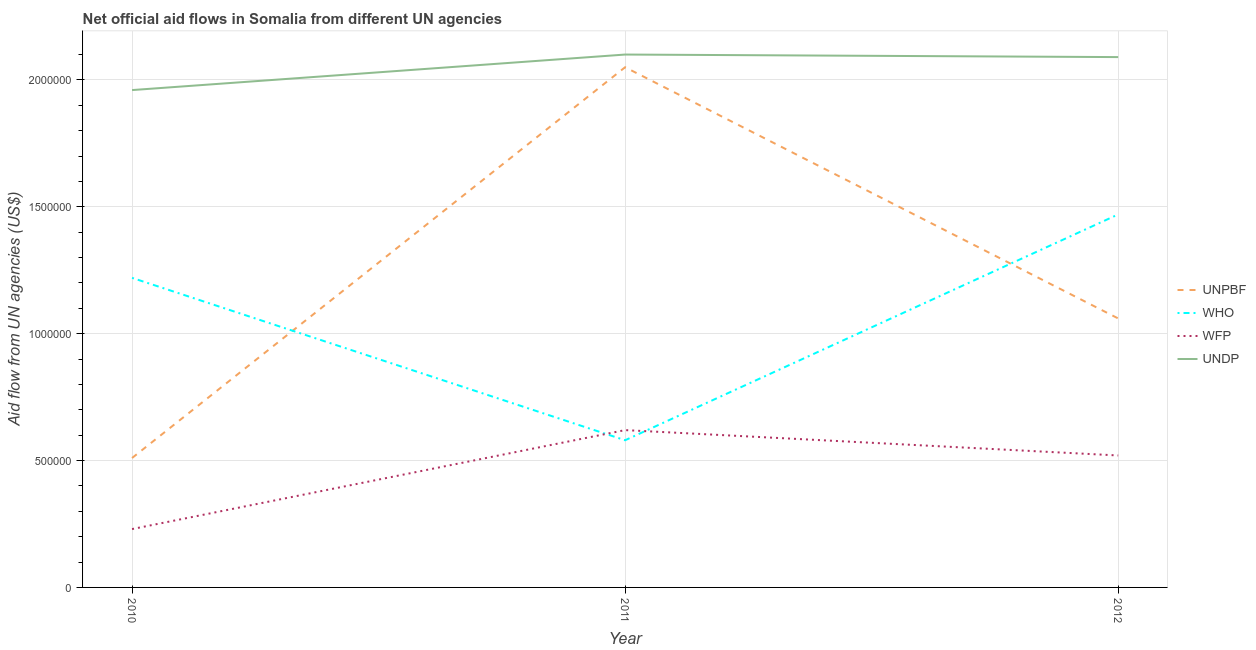What is the amount of aid given by wfp in 2010?
Keep it short and to the point. 2.30e+05. Across all years, what is the maximum amount of aid given by undp?
Ensure brevity in your answer.  2.10e+06. Across all years, what is the minimum amount of aid given by wfp?
Your answer should be compact. 2.30e+05. In which year was the amount of aid given by who maximum?
Offer a very short reply. 2012. In which year was the amount of aid given by wfp minimum?
Give a very brief answer. 2010. What is the total amount of aid given by who in the graph?
Your answer should be very brief. 3.27e+06. What is the difference between the amount of aid given by undp in 2010 and that in 2012?
Ensure brevity in your answer.  -1.30e+05. What is the difference between the amount of aid given by undp in 2012 and the amount of aid given by who in 2010?
Offer a very short reply. 8.70e+05. What is the average amount of aid given by who per year?
Your response must be concise. 1.09e+06. In the year 2012, what is the difference between the amount of aid given by unpbf and amount of aid given by who?
Give a very brief answer. -4.10e+05. In how many years, is the amount of aid given by unpbf greater than 2000000 US$?
Give a very brief answer. 1. What is the ratio of the amount of aid given by unpbf in 2010 to that in 2011?
Your response must be concise. 0.25. Is the amount of aid given by wfp in 2010 less than that in 2012?
Offer a terse response. Yes. Is the difference between the amount of aid given by who in 2011 and 2012 greater than the difference between the amount of aid given by wfp in 2011 and 2012?
Keep it short and to the point. No. What is the difference between the highest and the second highest amount of aid given by unpbf?
Give a very brief answer. 9.90e+05. What is the difference between the highest and the lowest amount of aid given by undp?
Offer a very short reply. 1.40e+05. Is it the case that in every year, the sum of the amount of aid given by wfp and amount of aid given by who is greater than the sum of amount of aid given by unpbf and amount of aid given by undp?
Give a very brief answer. Yes. Does the amount of aid given by unpbf monotonically increase over the years?
Offer a very short reply. No. Is the amount of aid given by undp strictly greater than the amount of aid given by unpbf over the years?
Offer a terse response. Yes. How many lines are there?
Provide a short and direct response. 4. Does the graph contain any zero values?
Give a very brief answer. No. What is the title of the graph?
Provide a succinct answer. Net official aid flows in Somalia from different UN agencies. Does "Interest Payments" appear as one of the legend labels in the graph?
Offer a terse response. No. What is the label or title of the X-axis?
Your answer should be very brief. Year. What is the label or title of the Y-axis?
Offer a very short reply. Aid flow from UN agencies (US$). What is the Aid flow from UN agencies (US$) in UNPBF in 2010?
Your answer should be very brief. 5.10e+05. What is the Aid flow from UN agencies (US$) of WHO in 2010?
Your answer should be very brief. 1.22e+06. What is the Aid flow from UN agencies (US$) in UNDP in 2010?
Provide a short and direct response. 1.96e+06. What is the Aid flow from UN agencies (US$) of UNPBF in 2011?
Your answer should be compact. 2.05e+06. What is the Aid flow from UN agencies (US$) of WHO in 2011?
Give a very brief answer. 5.80e+05. What is the Aid flow from UN agencies (US$) of WFP in 2011?
Offer a terse response. 6.20e+05. What is the Aid flow from UN agencies (US$) of UNDP in 2011?
Provide a short and direct response. 2.10e+06. What is the Aid flow from UN agencies (US$) in UNPBF in 2012?
Offer a terse response. 1.06e+06. What is the Aid flow from UN agencies (US$) of WHO in 2012?
Offer a terse response. 1.47e+06. What is the Aid flow from UN agencies (US$) in WFP in 2012?
Offer a very short reply. 5.20e+05. What is the Aid flow from UN agencies (US$) in UNDP in 2012?
Ensure brevity in your answer.  2.09e+06. Across all years, what is the maximum Aid flow from UN agencies (US$) in UNPBF?
Offer a terse response. 2.05e+06. Across all years, what is the maximum Aid flow from UN agencies (US$) of WHO?
Your answer should be very brief. 1.47e+06. Across all years, what is the maximum Aid flow from UN agencies (US$) of WFP?
Provide a short and direct response. 6.20e+05. Across all years, what is the maximum Aid flow from UN agencies (US$) in UNDP?
Your answer should be compact. 2.10e+06. Across all years, what is the minimum Aid flow from UN agencies (US$) in UNPBF?
Your answer should be very brief. 5.10e+05. Across all years, what is the minimum Aid flow from UN agencies (US$) of WHO?
Offer a terse response. 5.80e+05. Across all years, what is the minimum Aid flow from UN agencies (US$) of WFP?
Offer a very short reply. 2.30e+05. Across all years, what is the minimum Aid flow from UN agencies (US$) in UNDP?
Your answer should be compact. 1.96e+06. What is the total Aid flow from UN agencies (US$) in UNPBF in the graph?
Ensure brevity in your answer.  3.62e+06. What is the total Aid flow from UN agencies (US$) of WHO in the graph?
Make the answer very short. 3.27e+06. What is the total Aid flow from UN agencies (US$) of WFP in the graph?
Your response must be concise. 1.37e+06. What is the total Aid flow from UN agencies (US$) in UNDP in the graph?
Offer a terse response. 6.15e+06. What is the difference between the Aid flow from UN agencies (US$) in UNPBF in 2010 and that in 2011?
Make the answer very short. -1.54e+06. What is the difference between the Aid flow from UN agencies (US$) in WHO in 2010 and that in 2011?
Keep it short and to the point. 6.40e+05. What is the difference between the Aid flow from UN agencies (US$) of WFP in 2010 and that in 2011?
Provide a short and direct response. -3.90e+05. What is the difference between the Aid flow from UN agencies (US$) in UNDP in 2010 and that in 2011?
Make the answer very short. -1.40e+05. What is the difference between the Aid flow from UN agencies (US$) in UNPBF in 2010 and that in 2012?
Ensure brevity in your answer.  -5.50e+05. What is the difference between the Aid flow from UN agencies (US$) of WHO in 2010 and that in 2012?
Keep it short and to the point. -2.50e+05. What is the difference between the Aid flow from UN agencies (US$) of WFP in 2010 and that in 2012?
Offer a very short reply. -2.90e+05. What is the difference between the Aid flow from UN agencies (US$) in UNPBF in 2011 and that in 2012?
Provide a short and direct response. 9.90e+05. What is the difference between the Aid flow from UN agencies (US$) in WHO in 2011 and that in 2012?
Offer a very short reply. -8.90e+05. What is the difference between the Aid flow from UN agencies (US$) in UNDP in 2011 and that in 2012?
Offer a terse response. 10000. What is the difference between the Aid flow from UN agencies (US$) in UNPBF in 2010 and the Aid flow from UN agencies (US$) in WFP in 2011?
Make the answer very short. -1.10e+05. What is the difference between the Aid flow from UN agencies (US$) of UNPBF in 2010 and the Aid flow from UN agencies (US$) of UNDP in 2011?
Provide a succinct answer. -1.59e+06. What is the difference between the Aid flow from UN agencies (US$) in WHO in 2010 and the Aid flow from UN agencies (US$) in WFP in 2011?
Your answer should be compact. 6.00e+05. What is the difference between the Aid flow from UN agencies (US$) of WHO in 2010 and the Aid flow from UN agencies (US$) of UNDP in 2011?
Provide a short and direct response. -8.80e+05. What is the difference between the Aid flow from UN agencies (US$) of WFP in 2010 and the Aid flow from UN agencies (US$) of UNDP in 2011?
Your response must be concise. -1.87e+06. What is the difference between the Aid flow from UN agencies (US$) of UNPBF in 2010 and the Aid flow from UN agencies (US$) of WHO in 2012?
Offer a very short reply. -9.60e+05. What is the difference between the Aid flow from UN agencies (US$) in UNPBF in 2010 and the Aid flow from UN agencies (US$) in UNDP in 2012?
Your answer should be very brief. -1.58e+06. What is the difference between the Aid flow from UN agencies (US$) of WHO in 2010 and the Aid flow from UN agencies (US$) of UNDP in 2012?
Your answer should be compact. -8.70e+05. What is the difference between the Aid flow from UN agencies (US$) of WFP in 2010 and the Aid flow from UN agencies (US$) of UNDP in 2012?
Provide a succinct answer. -1.86e+06. What is the difference between the Aid flow from UN agencies (US$) in UNPBF in 2011 and the Aid flow from UN agencies (US$) in WHO in 2012?
Your answer should be compact. 5.80e+05. What is the difference between the Aid flow from UN agencies (US$) of UNPBF in 2011 and the Aid flow from UN agencies (US$) of WFP in 2012?
Offer a very short reply. 1.53e+06. What is the difference between the Aid flow from UN agencies (US$) in UNPBF in 2011 and the Aid flow from UN agencies (US$) in UNDP in 2012?
Ensure brevity in your answer.  -4.00e+04. What is the difference between the Aid flow from UN agencies (US$) in WHO in 2011 and the Aid flow from UN agencies (US$) in UNDP in 2012?
Provide a succinct answer. -1.51e+06. What is the difference between the Aid flow from UN agencies (US$) in WFP in 2011 and the Aid flow from UN agencies (US$) in UNDP in 2012?
Your response must be concise. -1.47e+06. What is the average Aid flow from UN agencies (US$) of UNPBF per year?
Keep it short and to the point. 1.21e+06. What is the average Aid flow from UN agencies (US$) in WHO per year?
Give a very brief answer. 1.09e+06. What is the average Aid flow from UN agencies (US$) in WFP per year?
Give a very brief answer. 4.57e+05. What is the average Aid flow from UN agencies (US$) in UNDP per year?
Make the answer very short. 2.05e+06. In the year 2010, what is the difference between the Aid flow from UN agencies (US$) of UNPBF and Aid flow from UN agencies (US$) of WHO?
Provide a succinct answer. -7.10e+05. In the year 2010, what is the difference between the Aid flow from UN agencies (US$) in UNPBF and Aid flow from UN agencies (US$) in UNDP?
Provide a short and direct response. -1.45e+06. In the year 2010, what is the difference between the Aid flow from UN agencies (US$) in WHO and Aid flow from UN agencies (US$) in WFP?
Ensure brevity in your answer.  9.90e+05. In the year 2010, what is the difference between the Aid flow from UN agencies (US$) in WHO and Aid flow from UN agencies (US$) in UNDP?
Your response must be concise. -7.40e+05. In the year 2010, what is the difference between the Aid flow from UN agencies (US$) of WFP and Aid flow from UN agencies (US$) of UNDP?
Provide a succinct answer. -1.73e+06. In the year 2011, what is the difference between the Aid flow from UN agencies (US$) of UNPBF and Aid flow from UN agencies (US$) of WHO?
Make the answer very short. 1.47e+06. In the year 2011, what is the difference between the Aid flow from UN agencies (US$) in UNPBF and Aid flow from UN agencies (US$) in WFP?
Offer a terse response. 1.43e+06. In the year 2011, what is the difference between the Aid flow from UN agencies (US$) of UNPBF and Aid flow from UN agencies (US$) of UNDP?
Make the answer very short. -5.00e+04. In the year 2011, what is the difference between the Aid flow from UN agencies (US$) in WHO and Aid flow from UN agencies (US$) in WFP?
Your response must be concise. -4.00e+04. In the year 2011, what is the difference between the Aid flow from UN agencies (US$) in WHO and Aid flow from UN agencies (US$) in UNDP?
Your answer should be compact. -1.52e+06. In the year 2011, what is the difference between the Aid flow from UN agencies (US$) of WFP and Aid flow from UN agencies (US$) of UNDP?
Provide a succinct answer. -1.48e+06. In the year 2012, what is the difference between the Aid flow from UN agencies (US$) of UNPBF and Aid flow from UN agencies (US$) of WHO?
Your answer should be very brief. -4.10e+05. In the year 2012, what is the difference between the Aid flow from UN agencies (US$) of UNPBF and Aid flow from UN agencies (US$) of WFP?
Provide a short and direct response. 5.40e+05. In the year 2012, what is the difference between the Aid flow from UN agencies (US$) of UNPBF and Aid flow from UN agencies (US$) of UNDP?
Your answer should be compact. -1.03e+06. In the year 2012, what is the difference between the Aid flow from UN agencies (US$) in WHO and Aid flow from UN agencies (US$) in WFP?
Offer a terse response. 9.50e+05. In the year 2012, what is the difference between the Aid flow from UN agencies (US$) in WHO and Aid flow from UN agencies (US$) in UNDP?
Ensure brevity in your answer.  -6.20e+05. In the year 2012, what is the difference between the Aid flow from UN agencies (US$) of WFP and Aid flow from UN agencies (US$) of UNDP?
Your answer should be compact. -1.57e+06. What is the ratio of the Aid flow from UN agencies (US$) of UNPBF in 2010 to that in 2011?
Your answer should be very brief. 0.25. What is the ratio of the Aid flow from UN agencies (US$) of WHO in 2010 to that in 2011?
Ensure brevity in your answer.  2.1. What is the ratio of the Aid flow from UN agencies (US$) in WFP in 2010 to that in 2011?
Your response must be concise. 0.37. What is the ratio of the Aid flow from UN agencies (US$) of UNDP in 2010 to that in 2011?
Offer a very short reply. 0.93. What is the ratio of the Aid flow from UN agencies (US$) of UNPBF in 2010 to that in 2012?
Your answer should be compact. 0.48. What is the ratio of the Aid flow from UN agencies (US$) in WHO in 2010 to that in 2012?
Make the answer very short. 0.83. What is the ratio of the Aid flow from UN agencies (US$) in WFP in 2010 to that in 2012?
Keep it short and to the point. 0.44. What is the ratio of the Aid flow from UN agencies (US$) in UNDP in 2010 to that in 2012?
Keep it short and to the point. 0.94. What is the ratio of the Aid flow from UN agencies (US$) in UNPBF in 2011 to that in 2012?
Offer a terse response. 1.93. What is the ratio of the Aid flow from UN agencies (US$) of WHO in 2011 to that in 2012?
Your answer should be compact. 0.39. What is the ratio of the Aid flow from UN agencies (US$) of WFP in 2011 to that in 2012?
Provide a succinct answer. 1.19. What is the difference between the highest and the second highest Aid flow from UN agencies (US$) in UNPBF?
Your answer should be very brief. 9.90e+05. What is the difference between the highest and the second highest Aid flow from UN agencies (US$) of WHO?
Offer a very short reply. 2.50e+05. What is the difference between the highest and the second highest Aid flow from UN agencies (US$) of WFP?
Your response must be concise. 1.00e+05. What is the difference between the highest and the lowest Aid flow from UN agencies (US$) in UNPBF?
Ensure brevity in your answer.  1.54e+06. What is the difference between the highest and the lowest Aid flow from UN agencies (US$) in WHO?
Your answer should be very brief. 8.90e+05. What is the difference between the highest and the lowest Aid flow from UN agencies (US$) of UNDP?
Your answer should be compact. 1.40e+05. 